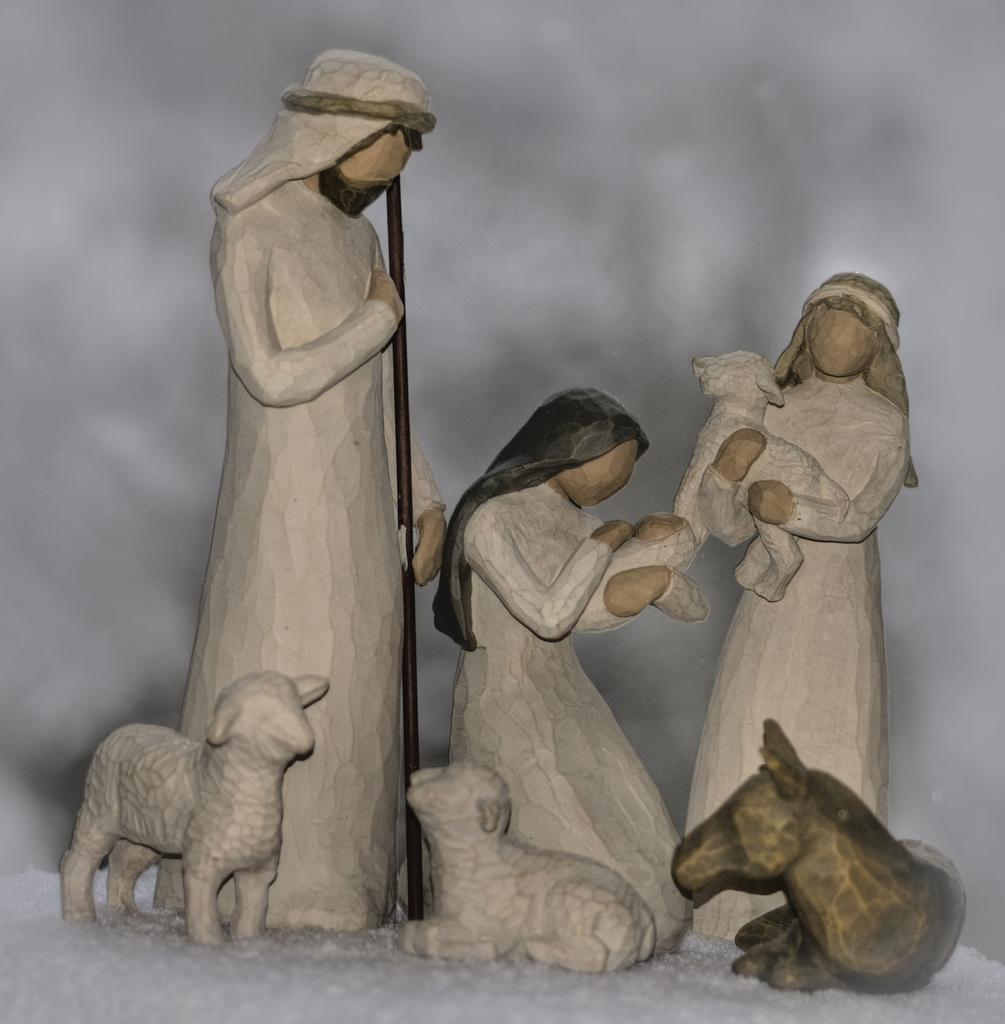What type of sculptures can be seen in the image? There are sculptures of people and animals in the image. Where are the sculptures located? The sculptures are on the surface in the image. What is the color of the background in the image? The background of the image is white. Can you tell me how many bats are flying in the image? There are no bats present in the image; it features sculptures of people and animals. What type of impulse can be seen affecting the sculptures in the image? There is no impulse affecting the sculptures in the image; it is a still image. 